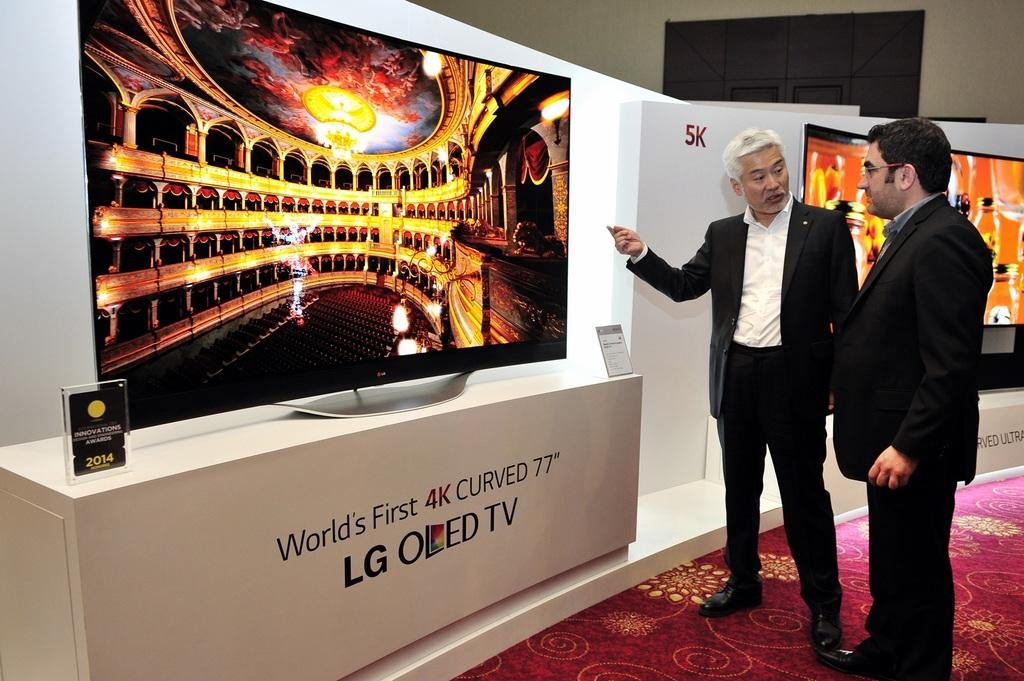<image>
Summarize the visual content of the image. a person standing next to an LG sign near them 